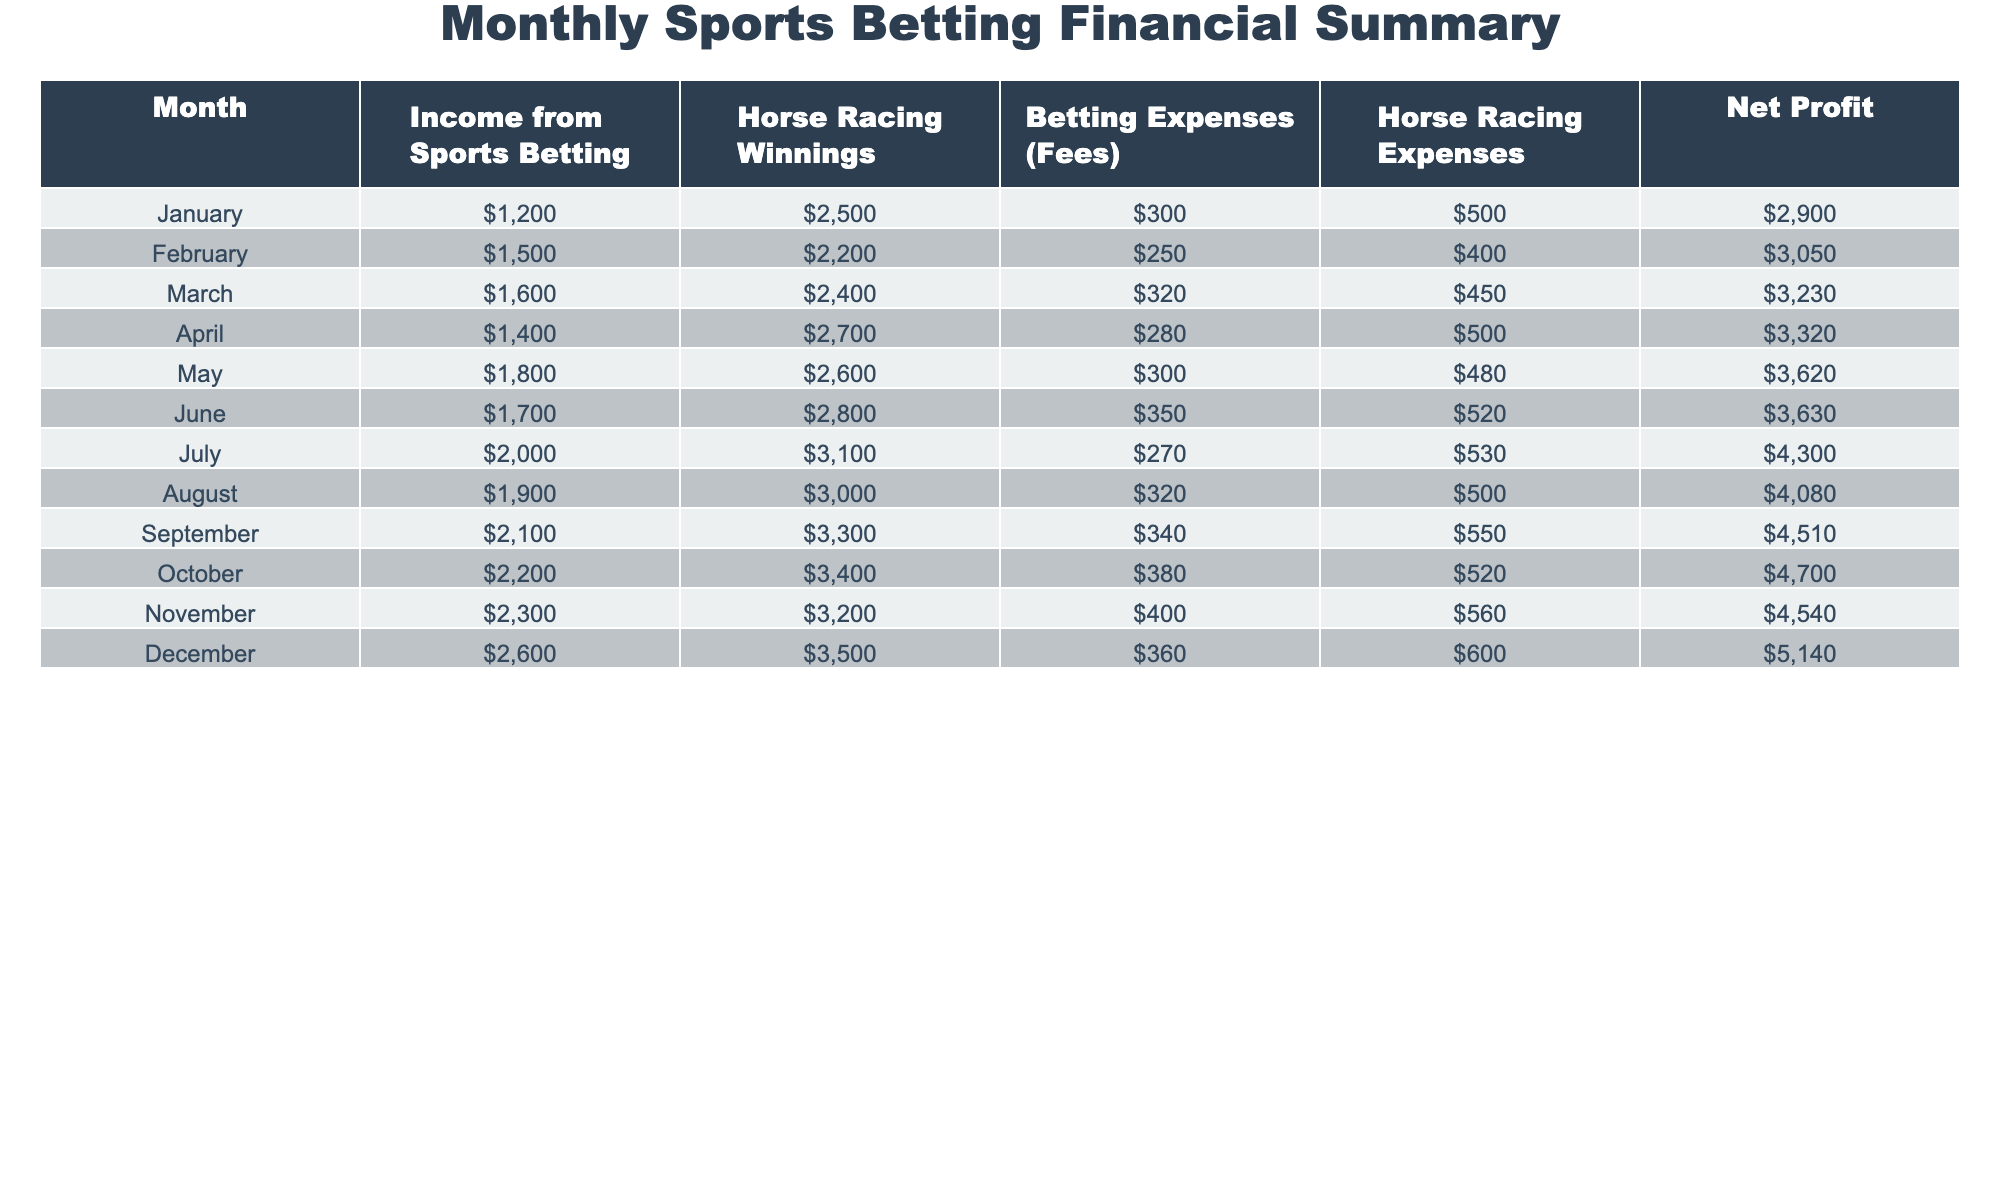What was the net profit for December? In the table, under the "Net Profit" column for December, the value is listed as 5140.
Answer: 5140 How much did I earn from Horse Racing Winnings in July? Looking at the "Horse Racing Winnings" column for July, the amount is 3100.
Answer: 3100 What is the total income from Sports Betting across all months? To find the total income from Sports Betting, I add up the values in the "Income from Sports Betting" column: 1200 + 1500 + 1600 + 1400 + 1800 + 1700 + 2000 + 1900 + 2100 + 2200 + 2300 + 2600 = 21700.
Answer: 21700 Did my Betting Expenses decrease from May to June? Comparing the "Betting Expenses (Fees)" for May (300) and June (350), it shows that expenses increased, so the answer is no.
Answer: No What is the average net profit for the first half of the year (January to June)? I calculate the average net profit by summing the values from the "Net Profit" column for January to June (2900 + 3050 + 3230 + 3320 + 3620 + 3630 = 19750), then divide by 6, which gives 19750 / 6 ≈ 3291.67.
Answer: 3291.67 How much more was spent on Horse Racing Expenses in November than in January? The "Horse Racing Expenses" in November is 560, and in January is 500. The difference is 560 - 500 = 60, indicating that I spent 60 more in November.
Answer: 60 What was the maximum income from Sports Betting and in which month did it occur? The maximum income is found by checking the "Income from Sports Betting" column, which is 2600 in December, as that is the highest value in the column.
Answer: 2600 in December Is the total betting expense higher in December than the average for the year? The total betting expense in December is 360, and I need to calculate the average by summing each month's expenses (300 + 250 + 320 + 280 + 300 + 350 + 270 + 320 + 340 + 380 + 400 + 360 = 3660), then divide by 12, which is 3660 / 12 = 305. Since 360 > 305, the statement is true.
Answer: Yes What was the trend of Horse Racing Winnings from March to October? By examining the "Horse Racing Winnings" column from March (2400) to October (3400), I see the winnings consistently increase each month, indicating a steady upward trend.
Answer: Steady upward trend 